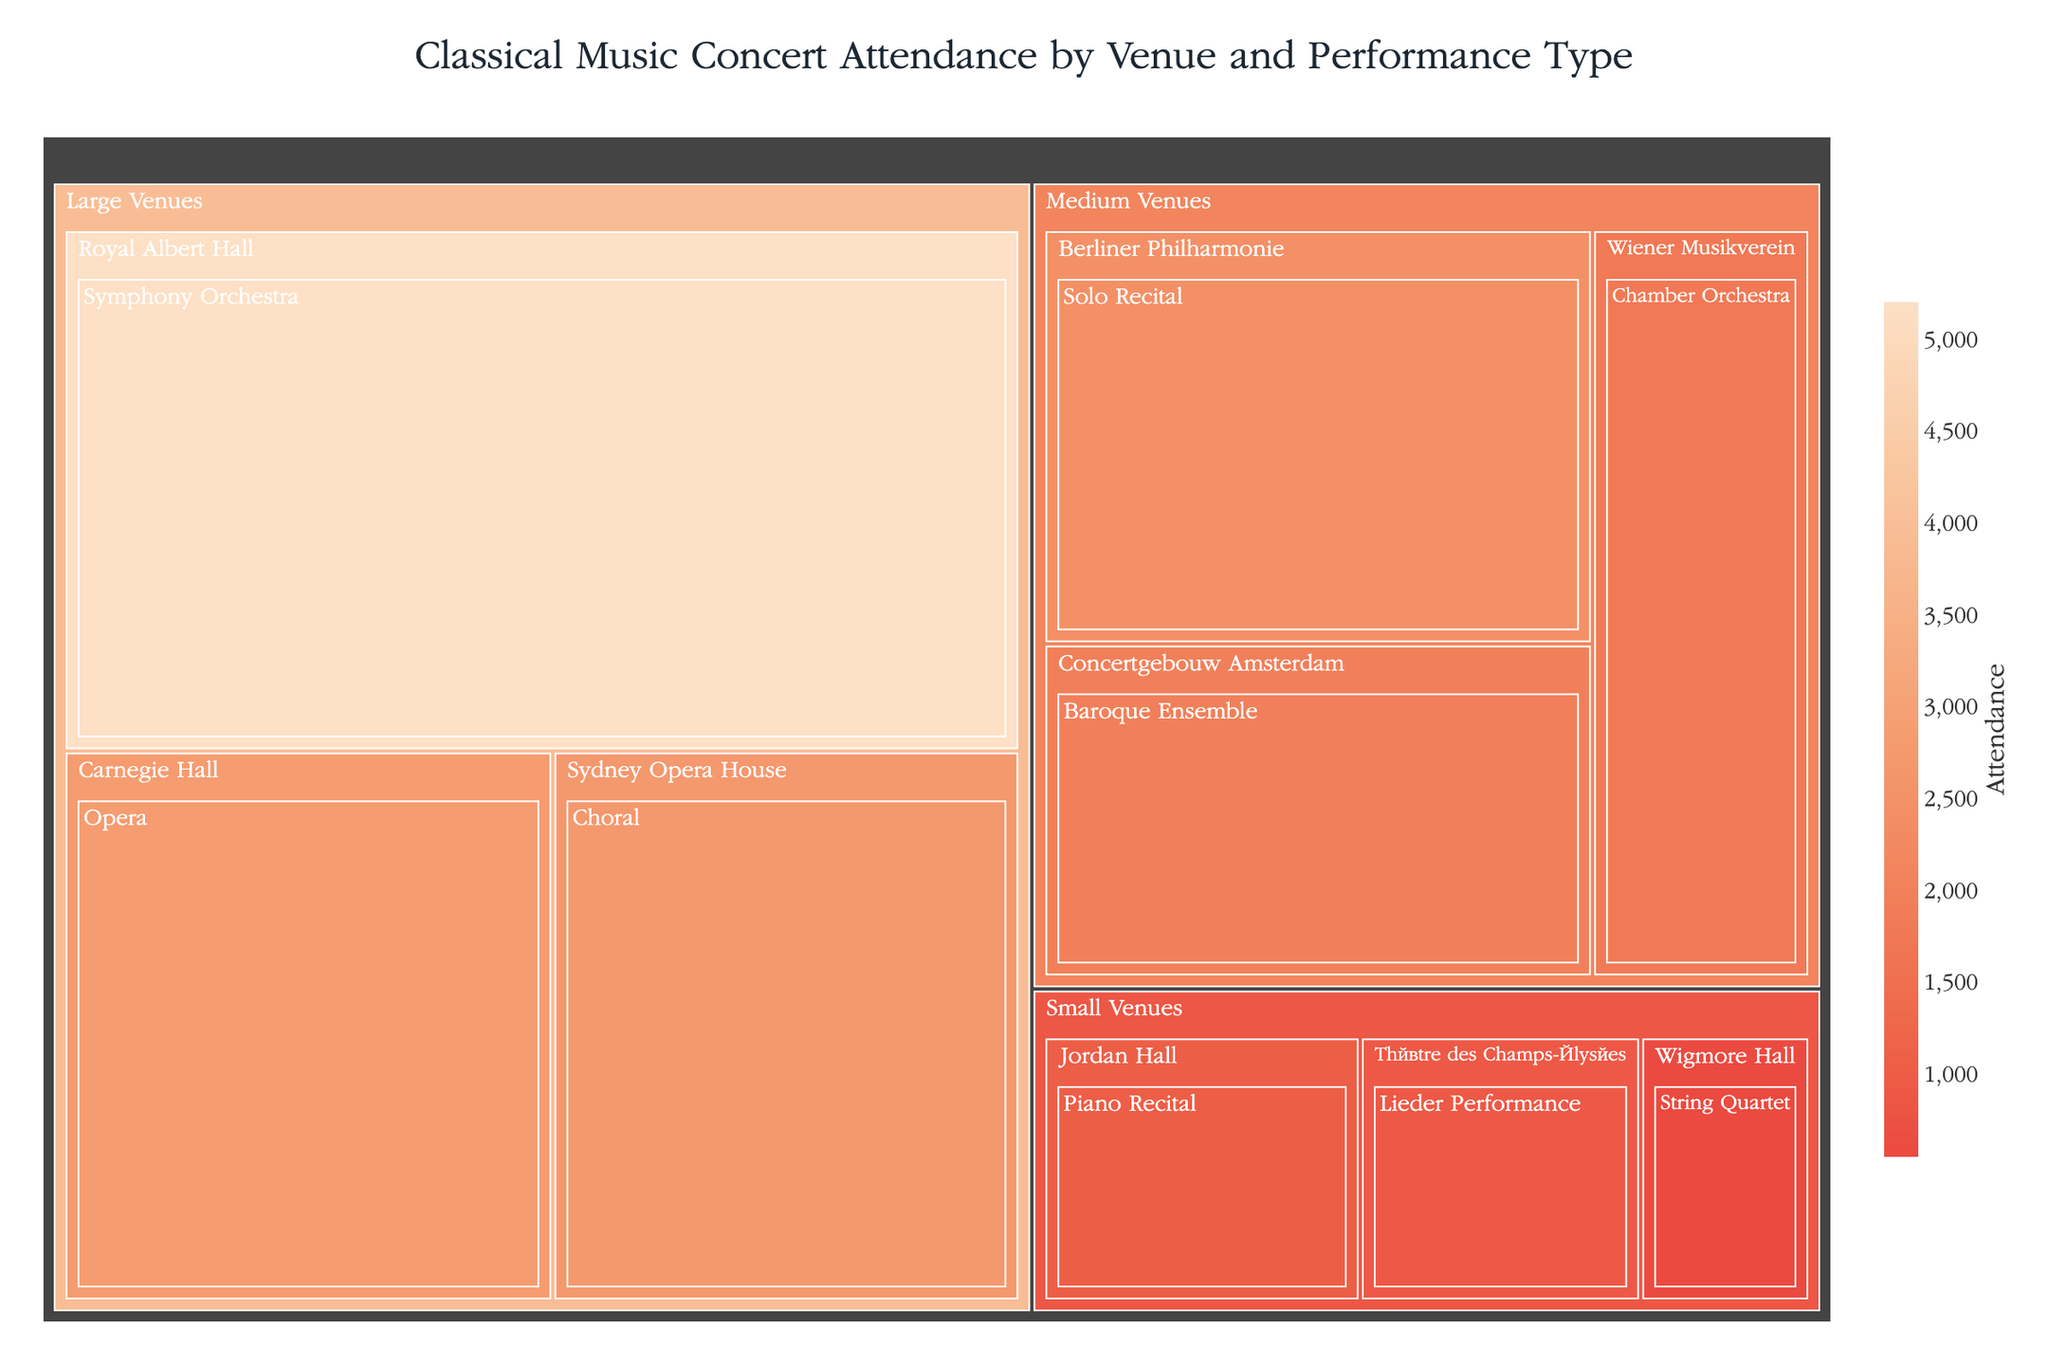What is the title of the Treemap? The title can be found at the top of the figure, describing the main topic of the plot.
Answer: Classical Music Concert Attendance by Venue and Performance Type Which performance type has the highest attendance in large venues? In the large venues category, the figure shows three different performance types. The performance type with the highest attendance has the largest area.
Answer: Symphony Orchestra What is the combined attendance for medium-sized venues? To find this, sum the attendance values for all performance types in medium venues: 1744 (Chamber Orchestra) + 2440 (Solo Recital) + 1962 (Baroque Ensemble).
Answer: 6146 Which specific venue has the lowest attendance, and what type of performance is it associated with? Look for the smallest box in the Treemap and check its associated labels for venue and performance type.
Answer: Wigmore Hall, String Quartet How does the attendance of Opera at Carnegie Hall compare to a Baroque Ensemble at Concertgebouw Amsterdam? Compare the attendance values displayed in the Treemap for these two entries.
Answer: Opera at Carnegie Hall has higher attendance (2804) than Baroque Ensemble at Concertgebouw Amsterdam (1962) Among medium venues, which performance type had the highest attendance, and by how much did it exceed the second highest? Identify the performance with the highest attendance in the medium venues category and then the second highest. Subtract the attendance of the second highest from the highest.
Answer: Solo Recital; exceeded by 744 What is the total attendance for small venues? Add the attendance values for all performance types in small venues: 545 (String Quartet) + 1019 (Piano Recital) + 903 (Lieder Performance).
Answer: 2467 Which venue category has the highest total attendance, and what is that attendance? Sum the attendance values within each venue category and compare totals to find the highest.
Answer: Large Venues; 10683 How many performance types have attendance greater than 2000? Count the number of performance types across all venues where the attendance value is above 2000.
Answer: 3 What is the average attendance for Symphony Orchestra performances across all venues? Find Symphony Orchestra entries and calculate their average attendance. There's only one Symphony Orchestra entry: 5200. Hence the average is simply the attendance of that entry.
Answer: 5200 